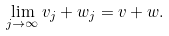<formula> <loc_0><loc_0><loc_500><loc_500>\lim _ { j \to \infty } v _ { j } + w _ { j } = v + w .</formula> 